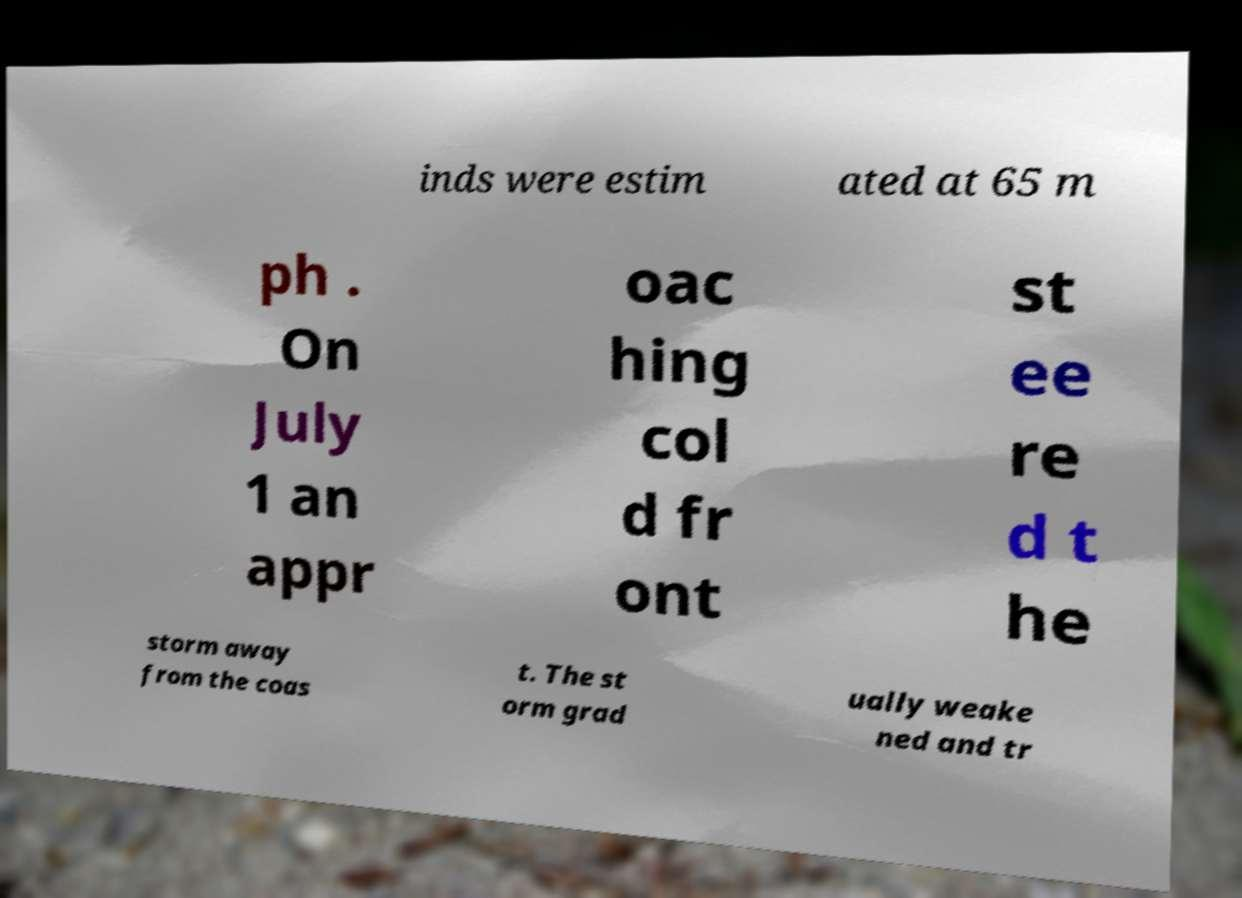Please identify and transcribe the text found in this image. inds were estim ated at 65 m ph . On July 1 an appr oac hing col d fr ont st ee re d t he storm away from the coas t. The st orm grad ually weake ned and tr 